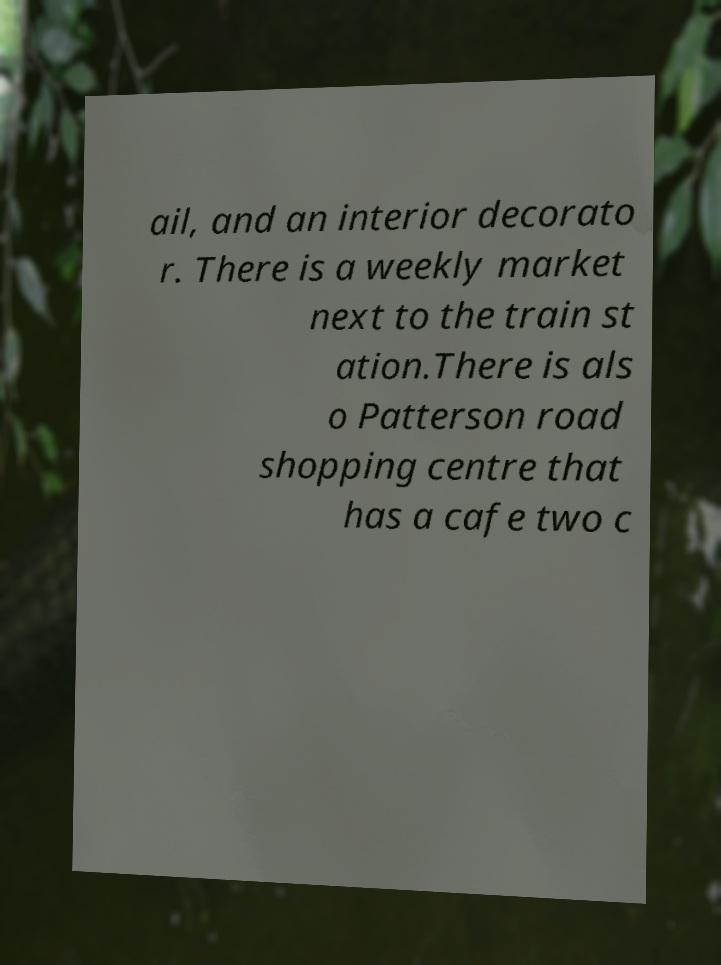Can you accurately transcribe the text from the provided image for me? ail, and an interior decorato r. There is a weekly market next to the train st ation.There is als o Patterson road shopping centre that has a cafe two c 